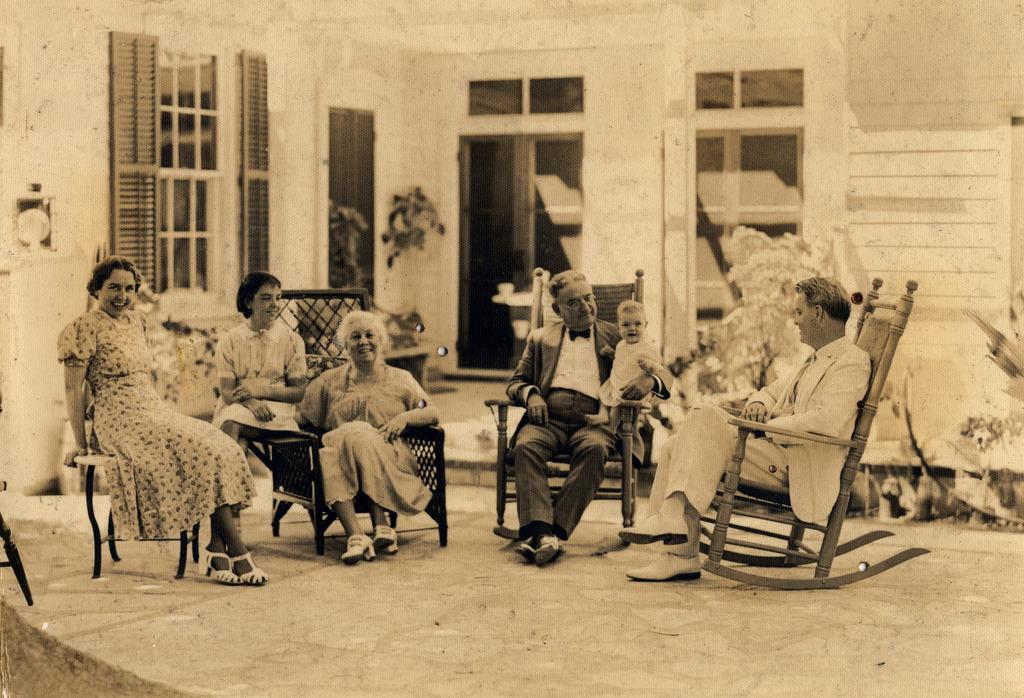How many people are in the image? There are five persons in the image. Can you describe the youngest person in the image? There is a baby in the image. What is the general mood of the people in the image? All the persons, including the baby, have smiles on their faces, indicating a happy or positive mood. What type of trucks can be seen in the image? There are no trucks present in the image. What offer is being made by the baby in the image? The baby is not making any offer in the image; they are simply present with the other people. 